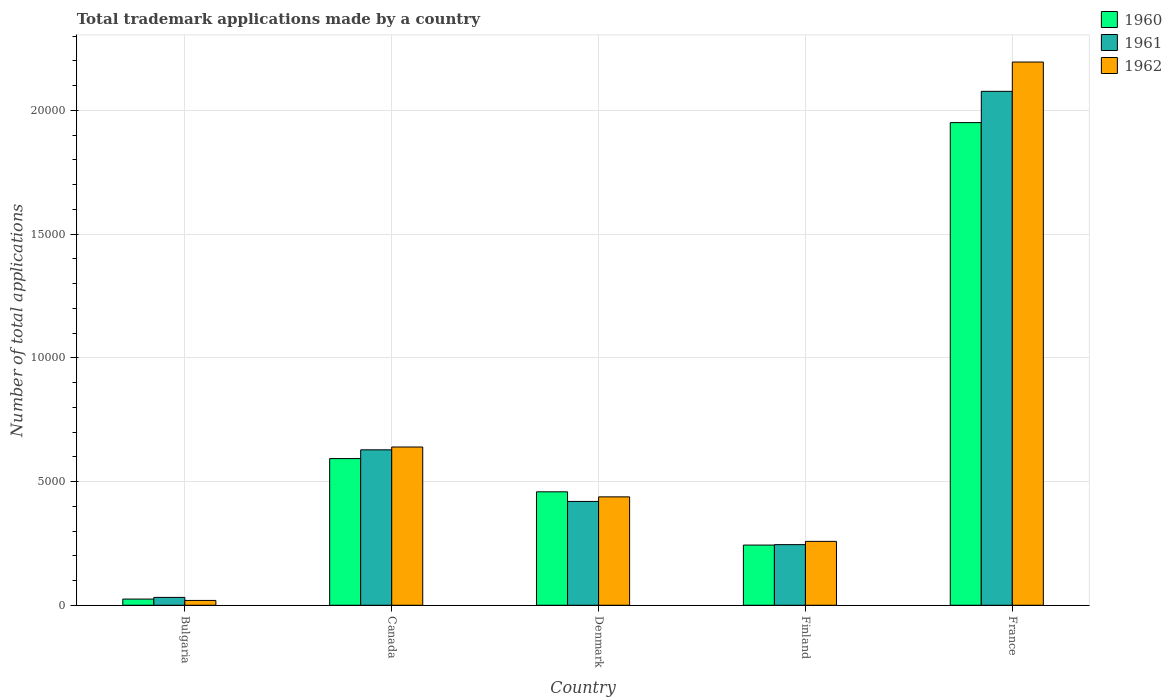How many different coloured bars are there?
Offer a very short reply. 3. What is the label of the 5th group of bars from the left?
Make the answer very short. France. What is the number of applications made by in 1960 in Finland?
Offer a terse response. 2432. Across all countries, what is the maximum number of applications made by in 1960?
Provide a succinct answer. 1.95e+04. Across all countries, what is the minimum number of applications made by in 1960?
Your answer should be compact. 250. In which country was the number of applications made by in 1962 maximum?
Make the answer very short. France. What is the total number of applications made by in 1961 in the graph?
Provide a succinct answer. 3.40e+04. What is the difference between the number of applications made by in 1962 in Denmark and that in France?
Your answer should be compact. -1.76e+04. What is the difference between the number of applications made by in 1962 in Denmark and the number of applications made by in 1960 in Canada?
Give a very brief answer. -1547. What is the average number of applications made by in 1962 per country?
Your response must be concise. 7100.8. What is the difference between the number of applications made by of/in 1960 and number of applications made by of/in 1961 in Denmark?
Your answer should be very brief. 388. In how many countries, is the number of applications made by in 1961 greater than 6000?
Offer a very short reply. 2. What is the ratio of the number of applications made by in 1960 in Finland to that in France?
Keep it short and to the point. 0.12. Is the difference between the number of applications made by in 1960 in Finland and France greater than the difference between the number of applications made by in 1961 in Finland and France?
Your response must be concise. Yes. What is the difference between the highest and the second highest number of applications made by in 1960?
Offer a terse response. 1.49e+04. What is the difference between the highest and the lowest number of applications made by in 1961?
Give a very brief answer. 2.04e+04. In how many countries, is the number of applications made by in 1960 greater than the average number of applications made by in 1960 taken over all countries?
Your response must be concise. 1. What does the 1st bar from the right in France represents?
Keep it short and to the point. 1962. Is it the case that in every country, the sum of the number of applications made by in 1962 and number of applications made by in 1960 is greater than the number of applications made by in 1961?
Make the answer very short. Yes. What is the difference between two consecutive major ticks on the Y-axis?
Make the answer very short. 5000. Does the graph contain grids?
Ensure brevity in your answer.  Yes. Where does the legend appear in the graph?
Ensure brevity in your answer.  Top right. How many legend labels are there?
Your response must be concise. 3. What is the title of the graph?
Offer a terse response. Total trademark applications made by a country. What is the label or title of the Y-axis?
Give a very brief answer. Number of total applications. What is the Number of total applications in 1960 in Bulgaria?
Provide a short and direct response. 250. What is the Number of total applications in 1961 in Bulgaria?
Your response must be concise. 318. What is the Number of total applications in 1962 in Bulgaria?
Keep it short and to the point. 195. What is the Number of total applications in 1960 in Canada?
Your answer should be very brief. 5927. What is the Number of total applications of 1961 in Canada?
Ensure brevity in your answer.  6281. What is the Number of total applications in 1962 in Canada?
Offer a terse response. 6395. What is the Number of total applications in 1960 in Denmark?
Keep it short and to the point. 4584. What is the Number of total applications in 1961 in Denmark?
Make the answer very short. 4196. What is the Number of total applications of 1962 in Denmark?
Give a very brief answer. 4380. What is the Number of total applications of 1960 in Finland?
Your response must be concise. 2432. What is the Number of total applications of 1961 in Finland?
Provide a succinct answer. 2450. What is the Number of total applications of 1962 in Finland?
Your answer should be very brief. 2582. What is the Number of total applications of 1960 in France?
Provide a succinct answer. 1.95e+04. What is the Number of total applications in 1961 in France?
Ensure brevity in your answer.  2.08e+04. What is the Number of total applications in 1962 in France?
Offer a terse response. 2.20e+04. Across all countries, what is the maximum Number of total applications in 1960?
Offer a terse response. 1.95e+04. Across all countries, what is the maximum Number of total applications in 1961?
Provide a succinct answer. 2.08e+04. Across all countries, what is the maximum Number of total applications of 1962?
Your answer should be very brief. 2.20e+04. Across all countries, what is the minimum Number of total applications in 1960?
Offer a very short reply. 250. Across all countries, what is the minimum Number of total applications in 1961?
Offer a terse response. 318. Across all countries, what is the minimum Number of total applications in 1962?
Your response must be concise. 195. What is the total Number of total applications in 1960 in the graph?
Your answer should be compact. 3.27e+04. What is the total Number of total applications of 1961 in the graph?
Offer a very short reply. 3.40e+04. What is the total Number of total applications of 1962 in the graph?
Your answer should be compact. 3.55e+04. What is the difference between the Number of total applications of 1960 in Bulgaria and that in Canada?
Ensure brevity in your answer.  -5677. What is the difference between the Number of total applications of 1961 in Bulgaria and that in Canada?
Keep it short and to the point. -5963. What is the difference between the Number of total applications of 1962 in Bulgaria and that in Canada?
Give a very brief answer. -6200. What is the difference between the Number of total applications in 1960 in Bulgaria and that in Denmark?
Your answer should be compact. -4334. What is the difference between the Number of total applications in 1961 in Bulgaria and that in Denmark?
Provide a succinct answer. -3878. What is the difference between the Number of total applications in 1962 in Bulgaria and that in Denmark?
Make the answer very short. -4185. What is the difference between the Number of total applications of 1960 in Bulgaria and that in Finland?
Make the answer very short. -2182. What is the difference between the Number of total applications of 1961 in Bulgaria and that in Finland?
Provide a short and direct response. -2132. What is the difference between the Number of total applications in 1962 in Bulgaria and that in Finland?
Keep it short and to the point. -2387. What is the difference between the Number of total applications of 1960 in Bulgaria and that in France?
Offer a terse response. -1.93e+04. What is the difference between the Number of total applications of 1961 in Bulgaria and that in France?
Your answer should be very brief. -2.04e+04. What is the difference between the Number of total applications of 1962 in Bulgaria and that in France?
Your answer should be compact. -2.18e+04. What is the difference between the Number of total applications in 1960 in Canada and that in Denmark?
Your answer should be very brief. 1343. What is the difference between the Number of total applications of 1961 in Canada and that in Denmark?
Your answer should be very brief. 2085. What is the difference between the Number of total applications in 1962 in Canada and that in Denmark?
Your answer should be compact. 2015. What is the difference between the Number of total applications in 1960 in Canada and that in Finland?
Provide a short and direct response. 3495. What is the difference between the Number of total applications in 1961 in Canada and that in Finland?
Provide a short and direct response. 3831. What is the difference between the Number of total applications of 1962 in Canada and that in Finland?
Ensure brevity in your answer.  3813. What is the difference between the Number of total applications in 1960 in Canada and that in France?
Your answer should be very brief. -1.36e+04. What is the difference between the Number of total applications of 1961 in Canada and that in France?
Provide a short and direct response. -1.45e+04. What is the difference between the Number of total applications of 1962 in Canada and that in France?
Ensure brevity in your answer.  -1.56e+04. What is the difference between the Number of total applications in 1960 in Denmark and that in Finland?
Keep it short and to the point. 2152. What is the difference between the Number of total applications in 1961 in Denmark and that in Finland?
Offer a very short reply. 1746. What is the difference between the Number of total applications of 1962 in Denmark and that in Finland?
Make the answer very short. 1798. What is the difference between the Number of total applications in 1960 in Denmark and that in France?
Your answer should be compact. -1.49e+04. What is the difference between the Number of total applications of 1961 in Denmark and that in France?
Your response must be concise. -1.66e+04. What is the difference between the Number of total applications in 1962 in Denmark and that in France?
Give a very brief answer. -1.76e+04. What is the difference between the Number of total applications of 1960 in Finland and that in France?
Provide a short and direct response. -1.71e+04. What is the difference between the Number of total applications in 1961 in Finland and that in France?
Keep it short and to the point. -1.83e+04. What is the difference between the Number of total applications in 1962 in Finland and that in France?
Offer a very short reply. -1.94e+04. What is the difference between the Number of total applications of 1960 in Bulgaria and the Number of total applications of 1961 in Canada?
Keep it short and to the point. -6031. What is the difference between the Number of total applications in 1960 in Bulgaria and the Number of total applications in 1962 in Canada?
Give a very brief answer. -6145. What is the difference between the Number of total applications of 1961 in Bulgaria and the Number of total applications of 1962 in Canada?
Make the answer very short. -6077. What is the difference between the Number of total applications in 1960 in Bulgaria and the Number of total applications in 1961 in Denmark?
Offer a terse response. -3946. What is the difference between the Number of total applications of 1960 in Bulgaria and the Number of total applications of 1962 in Denmark?
Give a very brief answer. -4130. What is the difference between the Number of total applications of 1961 in Bulgaria and the Number of total applications of 1962 in Denmark?
Keep it short and to the point. -4062. What is the difference between the Number of total applications of 1960 in Bulgaria and the Number of total applications of 1961 in Finland?
Ensure brevity in your answer.  -2200. What is the difference between the Number of total applications of 1960 in Bulgaria and the Number of total applications of 1962 in Finland?
Give a very brief answer. -2332. What is the difference between the Number of total applications in 1961 in Bulgaria and the Number of total applications in 1962 in Finland?
Your answer should be compact. -2264. What is the difference between the Number of total applications in 1960 in Bulgaria and the Number of total applications in 1961 in France?
Your answer should be compact. -2.05e+04. What is the difference between the Number of total applications in 1960 in Bulgaria and the Number of total applications in 1962 in France?
Offer a terse response. -2.17e+04. What is the difference between the Number of total applications of 1961 in Bulgaria and the Number of total applications of 1962 in France?
Your answer should be compact. -2.16e+04. What is the difference between the Number of total applications in 1960 in Canada and the Number of total applications in 1961 in Denmark?
Your answer should be compact. 1731. What is the difference between the Number of total applications in 1960 in Canada and the Number of total applications in 1962 in Denmark?
Your answer should be very brief. 1547. What is the difference between the Number of total applications of 1961 in Canada and the Number of total applications of 1962 in Denmark?
Your response must be concise. 1901. What is the difference between the Number of total applications in 1960 in Canada and the Number of total applications in 1961 in Finland?
Offer a very short reply. 3477. What is the difference between the Number of total applications in 1960 in Canada and the Number of total applications in 1962 in Finland?
Provide a succinct answer. 3345. What is the difference between the Number of total applications of 1961 in Canada and the Number of total applications of 1962 in Finland?
Give a very brief answer. 3699. What is the difference between the Number of total applications of 1960 in Canada and the Number of total applications of 1961 in France?
Your answer should be compact. -1.48e+04. What is the difference between the Number of total applications of 1960 in Canada and the Number of total applications of 1962 in France?
Provide a succinct answer. -1.60e+04. What is the difference between the Number of total applications of 1961 in Canada and the Number of total applications of 1962 in France?
Offer a very short reply. -1.57e+04. What is the difference between the Number of total applications of 1960 in Denmark and the Number of total applications of 1961 in Finland?
Your response must be concise. 2134. What is the difference between the Number of total applications in 1960 in Denmark and the Number of total applications in 1962 in Finland?
Ensure brevity in your answer.  2002. What is the difference between the Number of total applications in 1961 in Denmark and the Number of total applications in 1962 in Finland?
Make the answer very short. 1614. What is the difference between the Number of total applications of 1960 in Denmark and the Number of total applications of 1961 in France?
Keep it short and to the point. -1.62e+04. What is the difference between the Number of total applications of 1960 in Denmark and the Number of total applications of 1962 in France?
Offer a terse response. -1.74e+04. What is the difference between the Number of total applications in 1961 in Denmark and the Number of total applications in 1962 in France?
Your response must be concise. -1.78e+04. What is the difference between the Number of total applications in 1960 in Finland and the Number of total applications in 1961 in France?
Give a very brief answer. -1.83e+04. What is the difference between the Number of total applications of 1960 in Finland and the Number of total applications of 1962 in France?
Give a very brief answer. -1.95e+04. What is the difference between the Number of total applications of 1961 in Finland and the Number of total applications of 1962 in France?
Your answer should be compact. -1.95e+04. What is the average Number of total applications in 1960 per country?
Make the answer very short. 6539.4. What is the average Number of total applications of 1961 per country?
Ensure brevity in your answer.  6802.6. What is the average Number of total applications of 1962 per country?
Make the answer very short. 7100.8. What is the difference between the Number of total applications of 1960 and Number of total applications of 1961 in Bulgaria?
Make the answer very short. -68. What is the difference between the Number of total applications in 1961 and Number of total applications in 1962 in Bulgaria?
Give a very brief answer. 123. What is the difference between the Number of total applications of 1960 and Number of total applications of 1961 in Canada?
Ensure brevity in your answer.  -354. What is the difference between the Number of total applications in 1960 and Number of total applications in 1962 in Canada?
Provide a short and direct response. -468. What is the difference between the Number of total applications in 1961 and Number of total applications in 1962 in Canada?
Offer a very short reply. -114. What is the difference between the Number of total applications of 1960 and Number of total applications of 1961 in Denmark?
Ensure brevity in your answer.  388. What is the difference between the Number of total applications of 1960 and Number of total applications of 1962 in Denmark?
Your response must be concise. 204. What is the difference between the Number of total applications of 1961 and Number of total applications of 1962 in Denmark?
Offer a very short reply. -184. What is the difference between the Number of total applications in 1960 and Number of total applications in 1961 in Finland?
Your response must be concise. -18. What is the difference between the Number of total applications of 1960 and Number of total applications of 1962 in Finland?
Offer a very short reply. -150. What is the difference between the Number of total applications in 1961 and Number of total applications in 1962 in Finland?
Provide a succinct answer. -132. What is the difference between the Number of total applications of 1960 and Number of total applications of 1961 in France?
Give a very brief answer. -1264. What is the difference between the Number of total applications in 1960 and Number of total applications in 1962 in France?
Give a very brief answer. -2448. What is the difference between the Number of total applications in 1961 and Number of total applications in 1962 in France?
Give a very brief answer. -1184. What is the ratio of the Number of total applications of 1960 in Bulgaria to that in Canada?
Offer a terse response. 0.04. What is the ratio of the Number of total applications in 1961 in Bulgaria to that in Canada?
Your response must be concise. 0.05. What is the ratio of the Number of total applications of 1962 in Bulgaria to that in Canada?
Ensure brevity in your answer.  0.03. What is the ratio of the Number of total applications in 1960 in Bulgaria to that in Denmark?
Your answer should be compact. 0.05. What is the ratio of the Number of total applications of 1961 in Bulgaria to that in Denmark?
Offer a very short reply. 0.08. What is the ratio of the Number of total applications of 1962 in Bulgaria to that in Denmark?
Give a very brief answer. 0.04. What is the ratio of the Number of total applications of 1960 in Bulgaria to that in Finland?
Make the answer very short. 0.1. What is the ratio of the Number of total applications in 1961 in Bulgaria to that in Finland?
Your response must be concise. 0.13. What is the ratio of the Number of total applications in 1962 in Bulgaria to that in Finland?
Give a very brief answer. 0.08. What is the ratio of the Number of total applications of 1960 in Bulgaria to that in France?
Keep it short and to the point. 0.01. What is the ratio of the Number of total applications of 1961 in Bulgaria to that in France?
Offer a very short reply. 0.02. What is the ratio of the Number of total applications of 1962 in Bulgaria to that in France?
Offer a terse response. 0.01. What is the ratio of the Number of total applications in 1960 in Canada to that in Denmark?
Your response must be concise. 1.29. What is the ratio of the Number of total applications of 1961 in Canada to that in Denmark?
Offer a very short reply. 1.5. What is the ratio of the Number of total applications of 1962 in Canada to that in Denmark?
Your answer should be very brief. 1.46. What is the ratio of the Number of total applications in 1960 in Canada to that in Finland?
Keep it short and to the point. 2.44. What is the ratio of the Number of total applications of 1961 in Canada to that in Finland?
Offer a very short reply. 2.56. What is the ratio of the Number of total applications in 1962 in Canada to that in Finland?
Give a very brief answer. 2.48. What is the ratio of the Number of total applications in 1960 in Canada to that in France?
Your answer should be very brief. 0.3. What is the ratio of the Number of total applications in 1961 in Canada to that in France?
Provide a short and direct response. 0.3. What is the ratio of the Number of total applications of 1962 in Canada to that in France?
Your answer should be very brief. 0.29. What is the ratio of the Number of total applications in 1960 in Denmark to that in Finland?
Offer a terse response. 1.88. What is the ratio of the Number of total applications in 1961 in Denmark to that in Finland?
Your answer should be very brief. 1.71. What is the ratio of the Number of total applications of 1962 in Denmark to that in Finland?
Provide a succinct answer. 1.7. What is the ratio of the Number of total applications of 1960 in Denmark to that in France?
Your answer should be very brief. 0.23. What is the ratio of the Number of total applications of 1961 in Denmark to that in France?
Provide a short and direct response. 0.2. What is the ratio of the Number of total applications in 1962 in Denmark to that in France?
Offer a terse response. 0.2. What is the ratio of the Number of total applications in 1960 in Finland to that in France?
Offer a terse response. 0.12. What is the ratio of the Number of total applications of 1961 in Finland to that in France?
Keep it short and to the point. 0.12. What is the ratio of the Number of total applications in 1962 in Finland to that in France?
Your answer should be very brief. 0.12. What is the difference between the highest and the second highest Number of total applications of 1960?
Give a very brief answer. 1.36e+04. What is the difference between the highest and the second highest Number of total applications in 1961?
Your answer should be compact. 1.45e+04. What is the difference between the highest and the second highest Number of total applications of 1962?
Offer a very short reply. 1.56e+04. What is the difference between the highest and the lowest Number of total applications in 1960?
Make the answer very short. 1.93e+04. What is the difference between the highest and the lowest Number of total applications in 1961?
Give a very brief answer. 2.04e+04. What is the difference between the highest and the lowest Number of total applications of 1962?
Make the answer very short. 2.18e+04. 